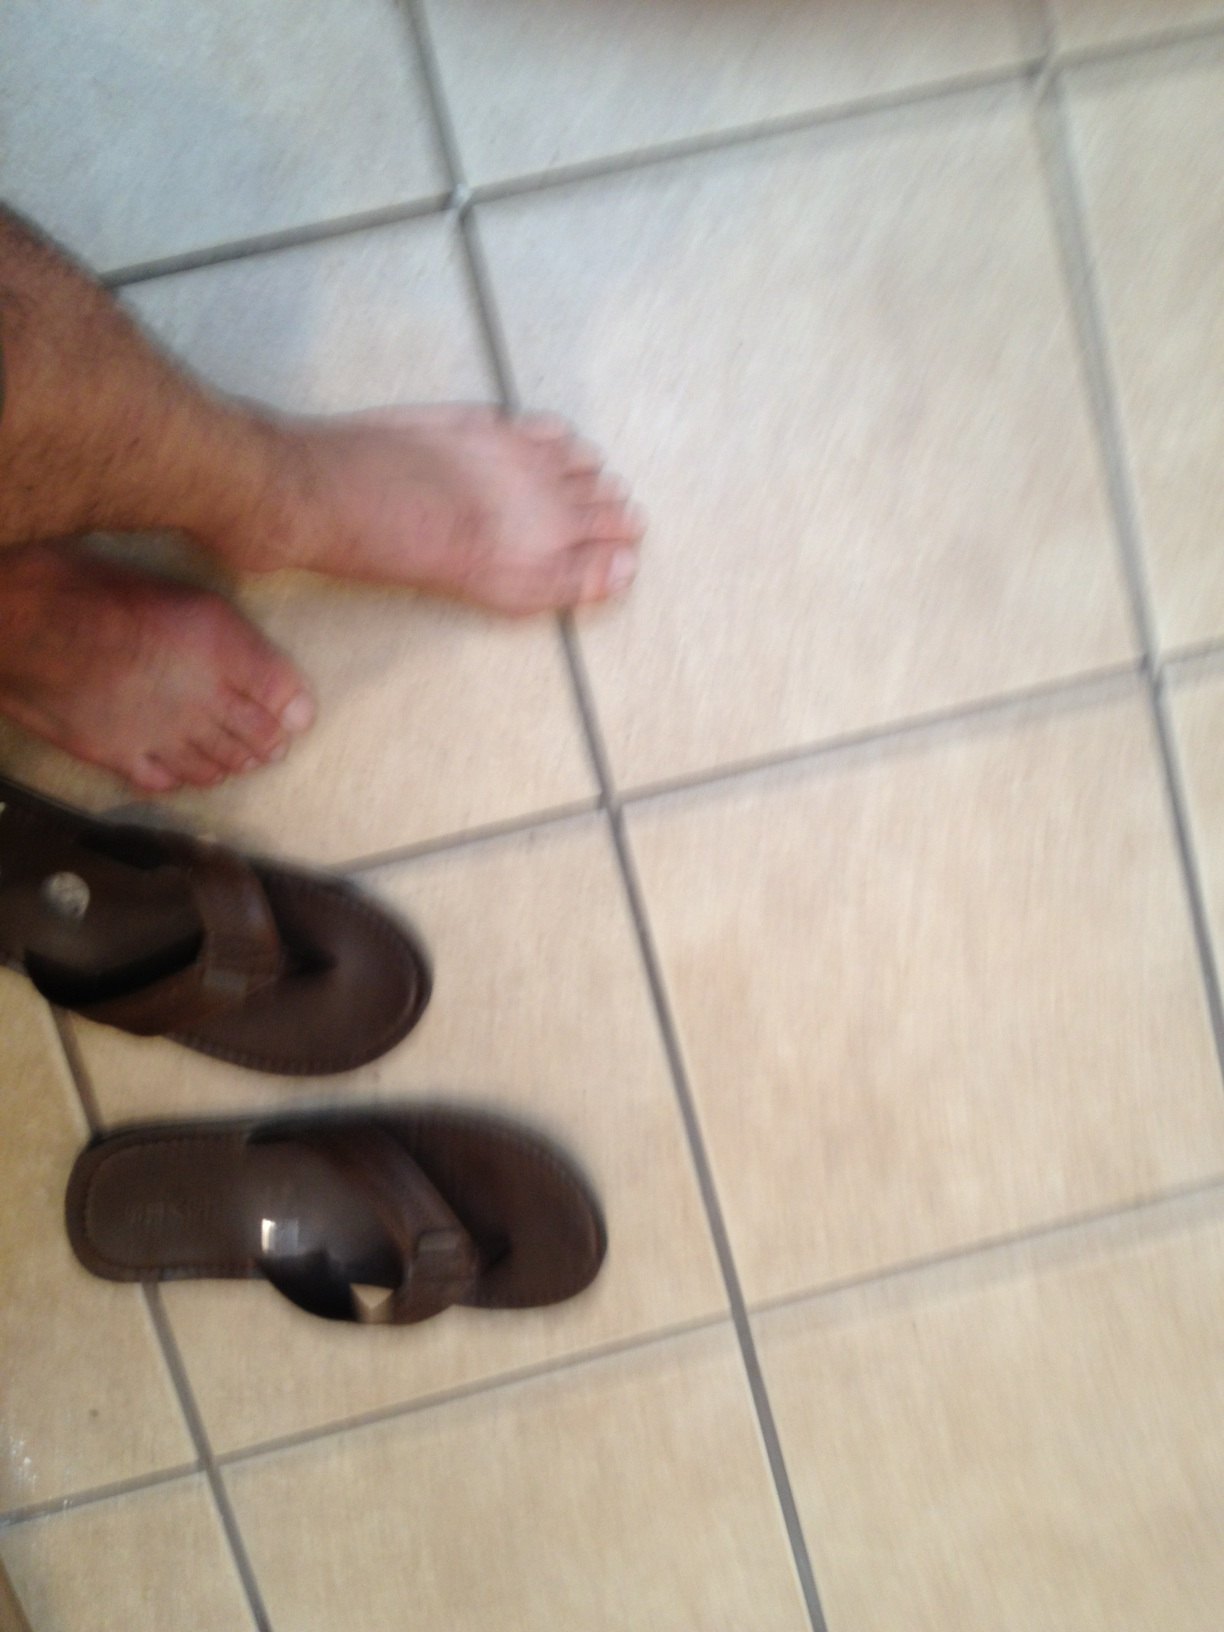What is the significance of the design of these flip flops? The brown flip flops have a simple and functional design, aimed at providing comfort and durability. The straps are wide for better foot support, and the sole is thick, which helps in cushioning and protecting the feet during walking. 